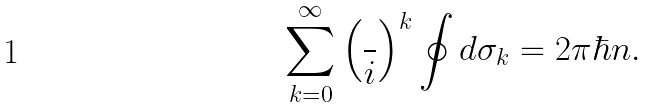<formula> <loc_0><loc_0><loc_500><loc_500>\sum _ { k = 0 } ^ { \infty } \left ( \frac { } { i } \right ) ^ { k } \oint d \sigma _ { k } = 2 \pi \hbar { n } .</formula> 